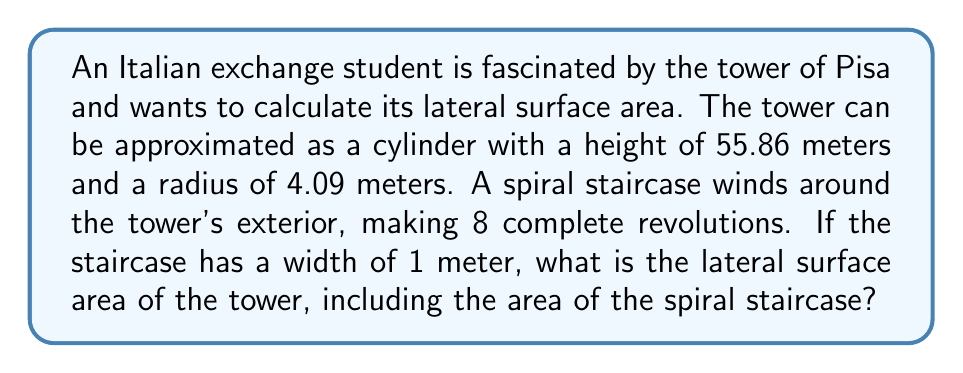Help me with this question. Let's approach this problem step by step:

1) First, we need to calculate the lateral surface area of the cylindrical tower without the staircase:
   $$A_{cylinder} = 2\pi rh$$
   where $r$ is the radius and $h$ is the height.
   $$A_{cylinder} = 2\pi(4.09)(55.86) = 1434.96 \text{ m}^2$$

2) Now, we need to calculate the area of the spiral staircase. The staircase forms a helix around the cylinder. The length of this helix can be calculated using the formula:
   $$L = \sqrt{(2\pi rn)^2 + h^2}$$
   where $n$ is the number of revolutions.
   $$L = \sqrt{(2\pi(4.09)(8))^2 + 55.86^2} = 206.37 \text{ m}$$

3) The area of the staircase is its length multiplied by its width:
   $$A_{staircase} = 206.37 \cdot 1 = 206.37 \text{ m}^2$$

4) The total lateral surface area is the sum of the cylinder's surface area and the staircase area:
   $$A_{total} = A_{cylinder} + A_{staircase} = 1434.96 + 206.37 = 1641.33 \text{ m}^2$$

Therefore, the total lateral surface area of the tower, including the spiral staircase, is approximately 1641.33 square meters.
Answer: $1641.33 \text{ m}^2$ 